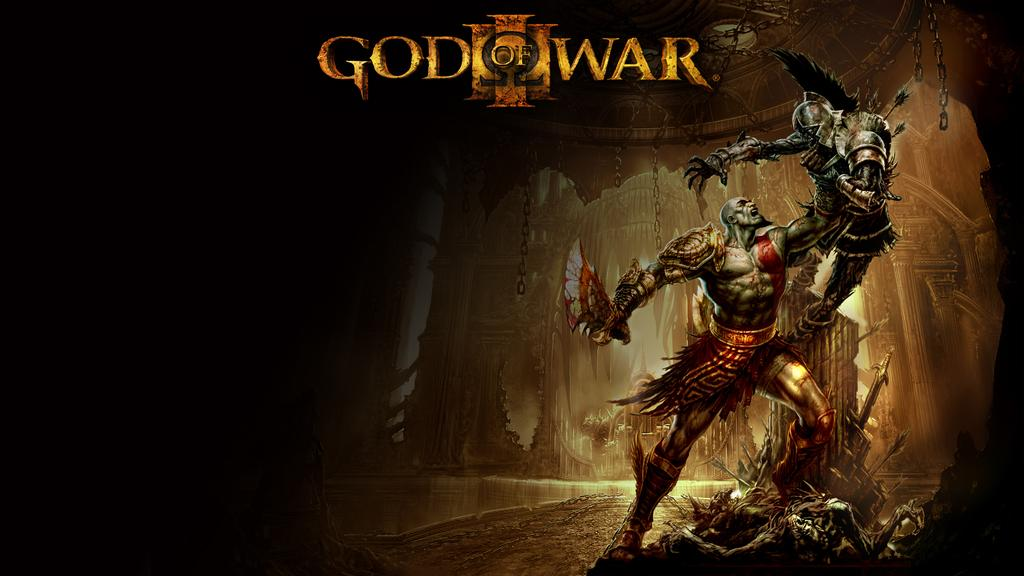<image>
Provide a brief description of the given image. a game that is called The God of War with a violent image 